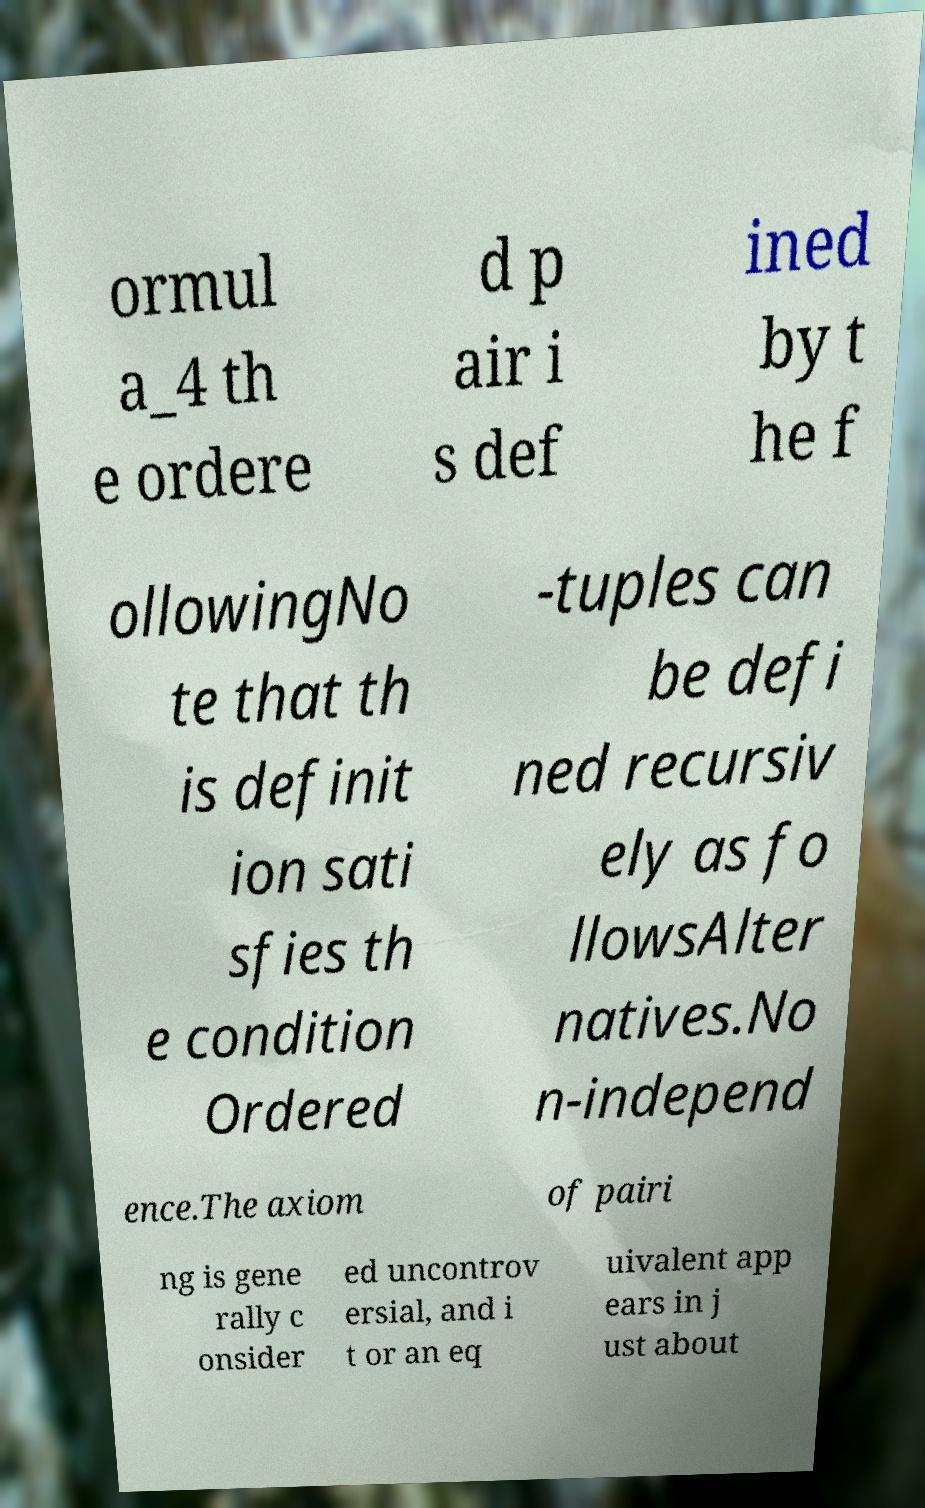I need the written content from this picture converted into text. Can you do that? ormul a_4 th e ordere d p air i s def ined by t he f ollowingNo te that th is definit ion sati sfies th e condition Ordered -tuples can be defi ned recursiv ely as fo llowsAlter natives.No n-independ ence.The axiom of pairi ng is gene rally c onsider ed uncontrov ersial, and i t or an eq uivalent app ears in j ust about 